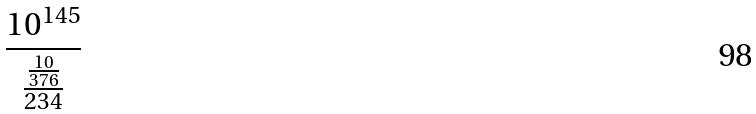Convert formula to latex. <formula><loc_0><loc_0><loc_500><loc_500>\frac { 1 0 ^ { 1 4 5 } } { \frac { \frac { 1 0 } { 3 7 6 } } { 2 3 4 } }</formula> 